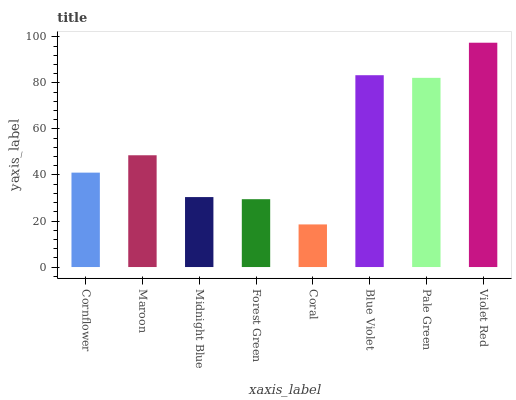Is Coral the minimum?
Answer yes or no. Yes. Is Violet Red the maximum?
Answer yes or no. Yes. Is Maroon the minimum?
Answer yes or no. No. Is Maroon the maximum?
Answer yes or no. No. Is Maroon greater than Cornflower?
Answer yes or no. Yes. Is Cornflower less than Maroon?
Answer yes or no. Yes. Is Cornflower greater than Maroon?
Answer yes or no. No. Is Maroon less than Cornflower?
Answer yes or no. No. Is Maroon the high median?
Answer yes or no. Yes. Is Cornflower the low median?
Answer yes or no. Yes. Is Pale Green the high median?
Answer yes or no. No. Is Blue Violet the low median?
Answer yes or no. No. 